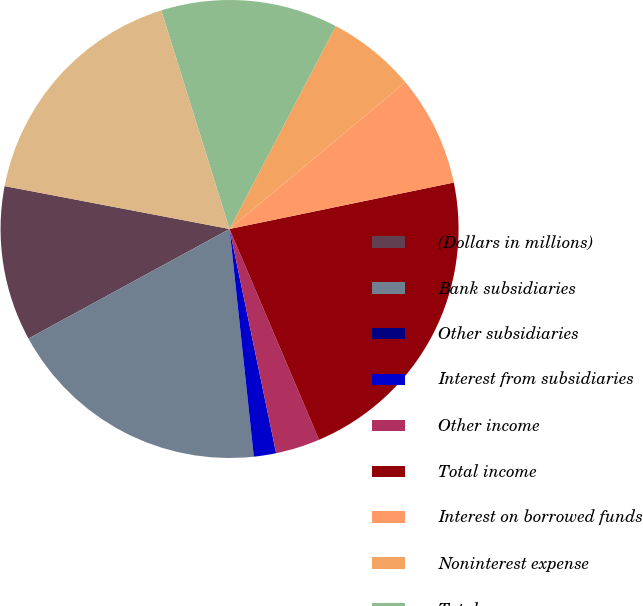Convert chart. <chart><loc_0><loc_0><loc_500><loc_500><pie_chart><fcel>(Dollars in millions)<fcel>Bank subsidiaries<fcel>Other subsidiaries<fcel>Interest from subsidiaries<fcel>Other income<fcel>Total income<fcel>Interest on borrowed funds<fcel>Noninterest expense<fcel>Total expense<fcel>Income before income taxes and<nl><fcel>10.94%<fcel>18.74%<fcel>0.01%<fcel>1.57%<fcel>3.13%<fcel>21.86%<fcel>7.82%<fcel>6.25%<fcel>12.5%<fcel>17.18%<nl></chart> 